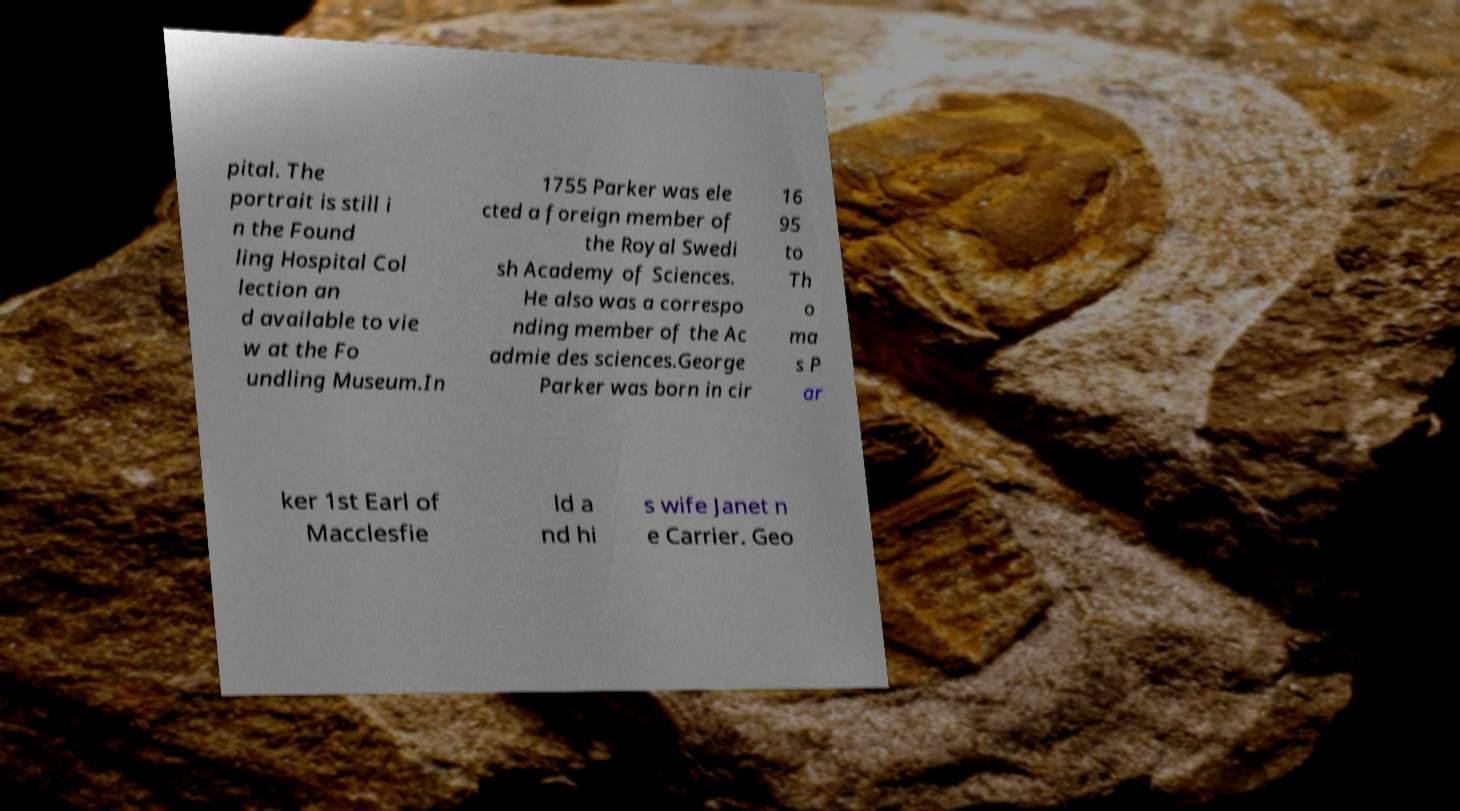There's text embedded in this image that I need extracted. Can you transcribe it verbatim? pital. The portrait is still i n the Found ling Hospital Col lection an d available to vie w at the Fo undling Museum.In 1755 Parker was ele cted a foreign member of the Royal Swedi sh Academy of Sciences. He also was a correspo nding member of the Ac admie des sciences.George Parker was born in cir 16 95 to Th o ma s P ar ker 1st Earl of Macclesfie ld a nd hi s wife Janet n e Carrier. Geo 